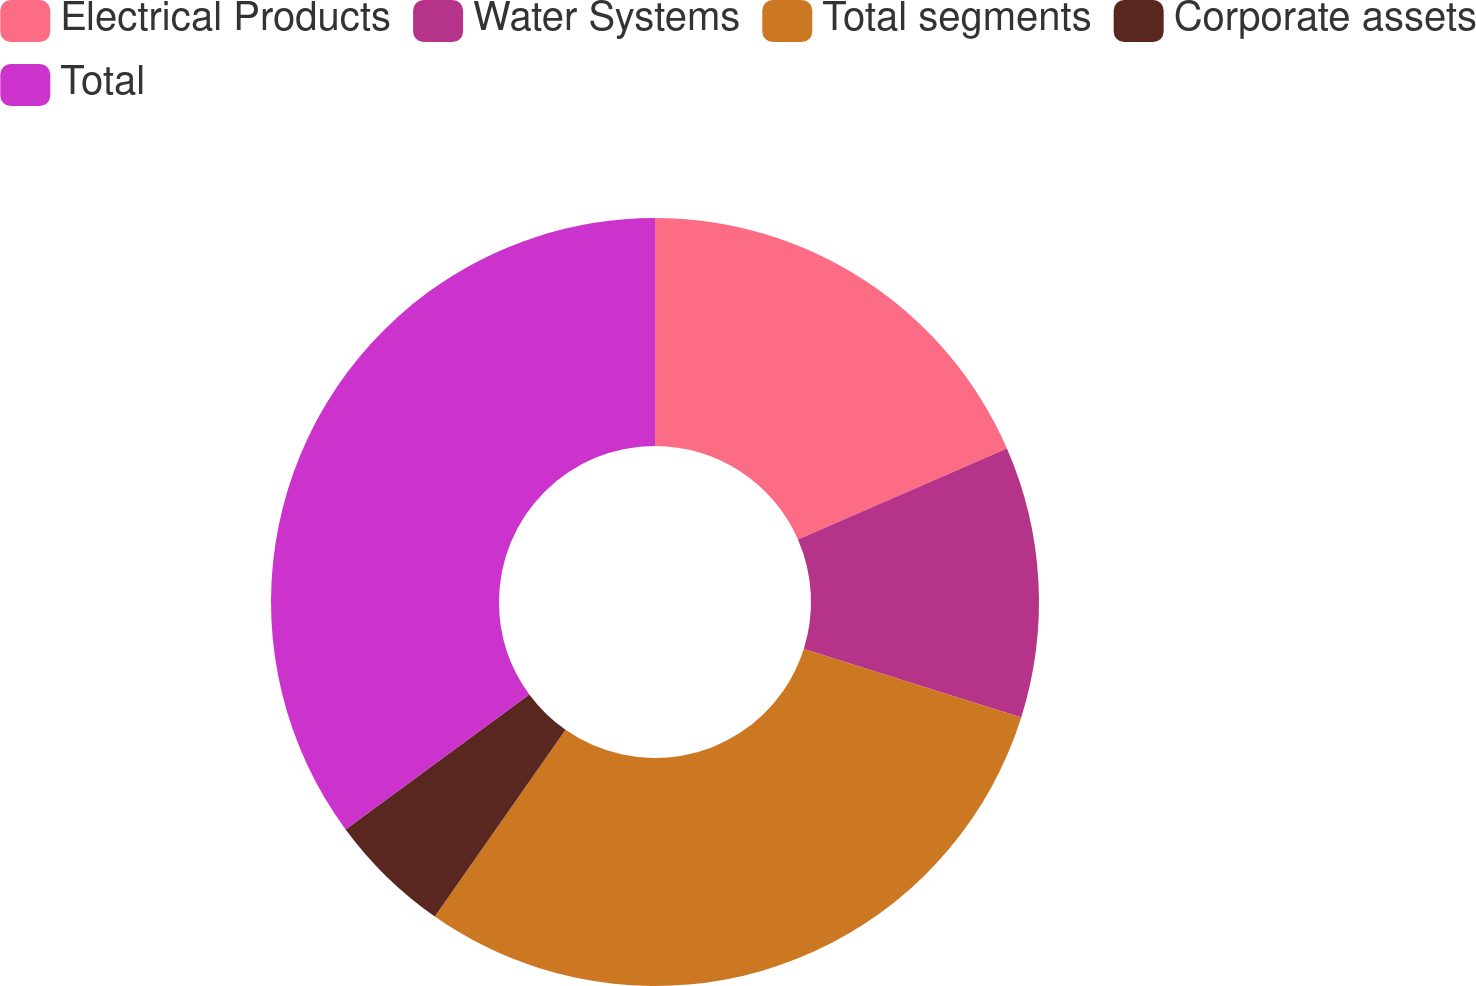Convert chart to OTSL. <chart><loc_0><loc_0><loc_500><loc_500><pie_chart><fcel>Electrical Products<fcel>Water Systems<fcel>Total segments<fcel>Corporate assets<fcel>Total<nl><fcel>18.45%<fcel>11.41%<fcel>29.86%<fcel>5.19%<fcel>35.09%<nl></chart> 